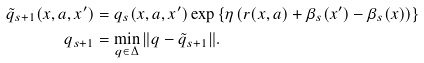<formula> <loc_0><loc_0><loc_500><loc_500>\tilde { q } _ { s + 1 } ( x , a , x ^ { \prime } ) & = q _ { s } ( x , a , x ^ { \prime } ) \exp \left \{ \eta \left ( r ( x , a ) + \beta _ { s } ( x ^ { \prime } ) - \beta _ { s } ( x ) \right ) \right \} \\ q _ { s + 1 } & = \min _ { q \in \Delta } \| q - \tilde { q } _ { s + 1 } \| .</formula> 